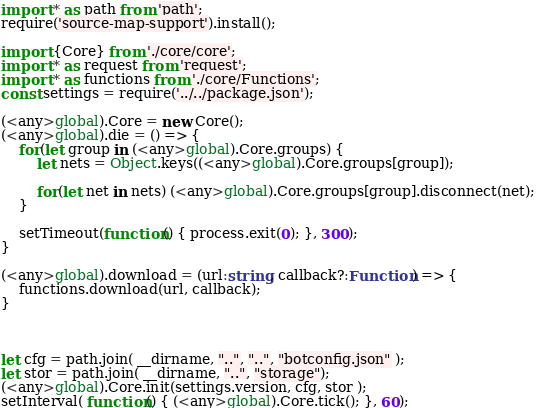Convert code to text. <code><loc_0><loc_0><loc_500><loc_500><_TypeScript_>import * as path from 'path';
require('source-map-support').install();

import {Core} from './core/core';
import * as request from 'request';
import * as functions from './core/Functions';
const settings = require('../../package.json');

(<any>global).Core = new Core();
(<any>global).die = () => {
    for(let group in (<any>global).Core.groups) {
        let nets = Object.keys((<any>global).Core.groups[group]);

        for(let net in nets) (<any>global).Core.groups[group].disconnect(net);
    }

    setTimeout(function() { process.exit(0); }, 300);
}

(<any>global).download = (url:string, callback?:Function) => {
    functions.download(url, callback);
}



let cfg = path.join( __dirname, "..", "..", "botconfig.json" );
let stor = path.join( __dirname, "..", "storage");
(<any>global).Core.init(settings.version, cfg, stor );
setInterval( function() { (<any>global).Core.tick(); }, 60);

</code> 